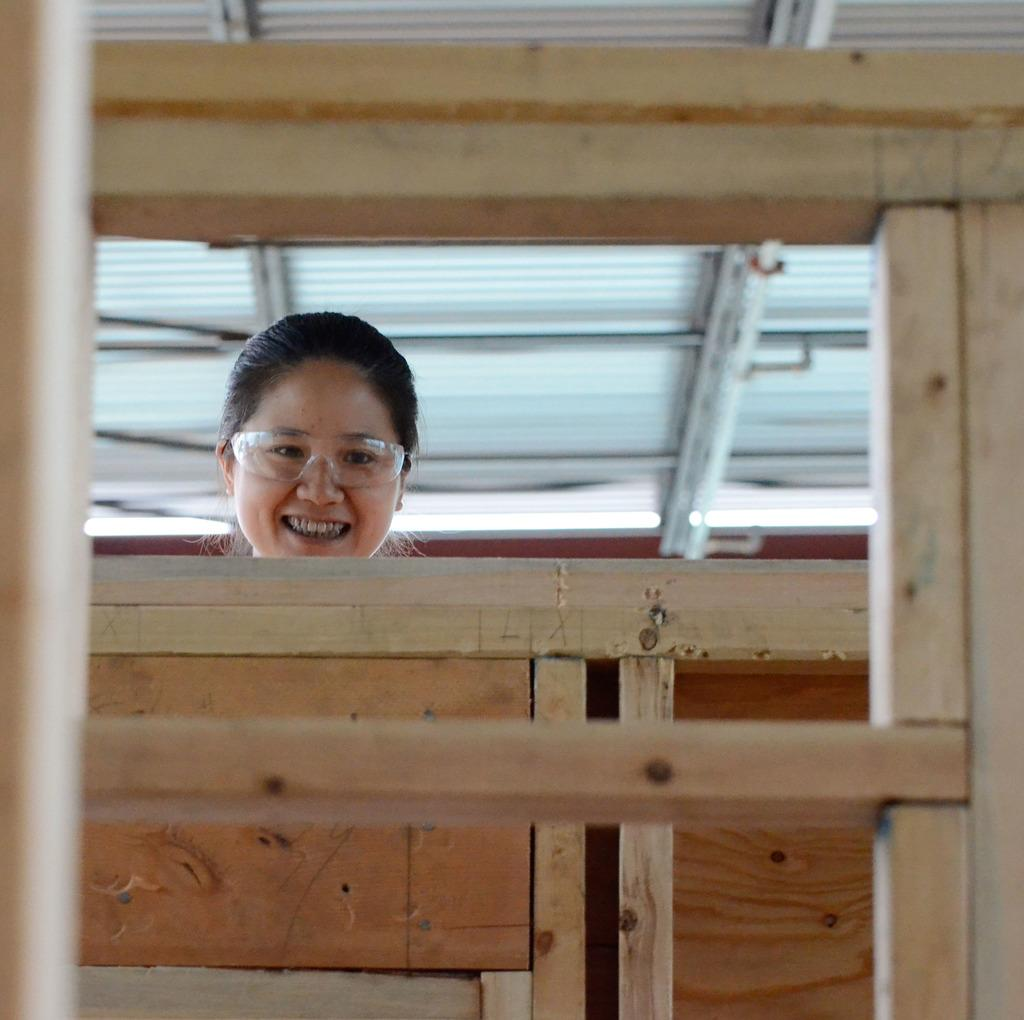Who is present in the image? There is a woman in the image. What is the woman's facial expression? The woman is smiling. What type of material is in front of the woman? There is a wooden material in front of the woman. What part of a building can be seen in the image? There is a roof visible in the image. What type of steel is the woman using to eat her breakfast in the image? There is no steel or breakfast present in the image. What is the woman doing with her tooth in the image? There is no tooth or activity involving a tooth present in the image. 